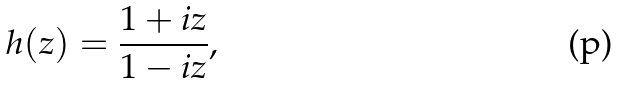<formula> <loc_0><loc_0><loc_500><loc_500>h ( z ) = \frac { 1 + i z } { 1 - i z } ,</formula> 